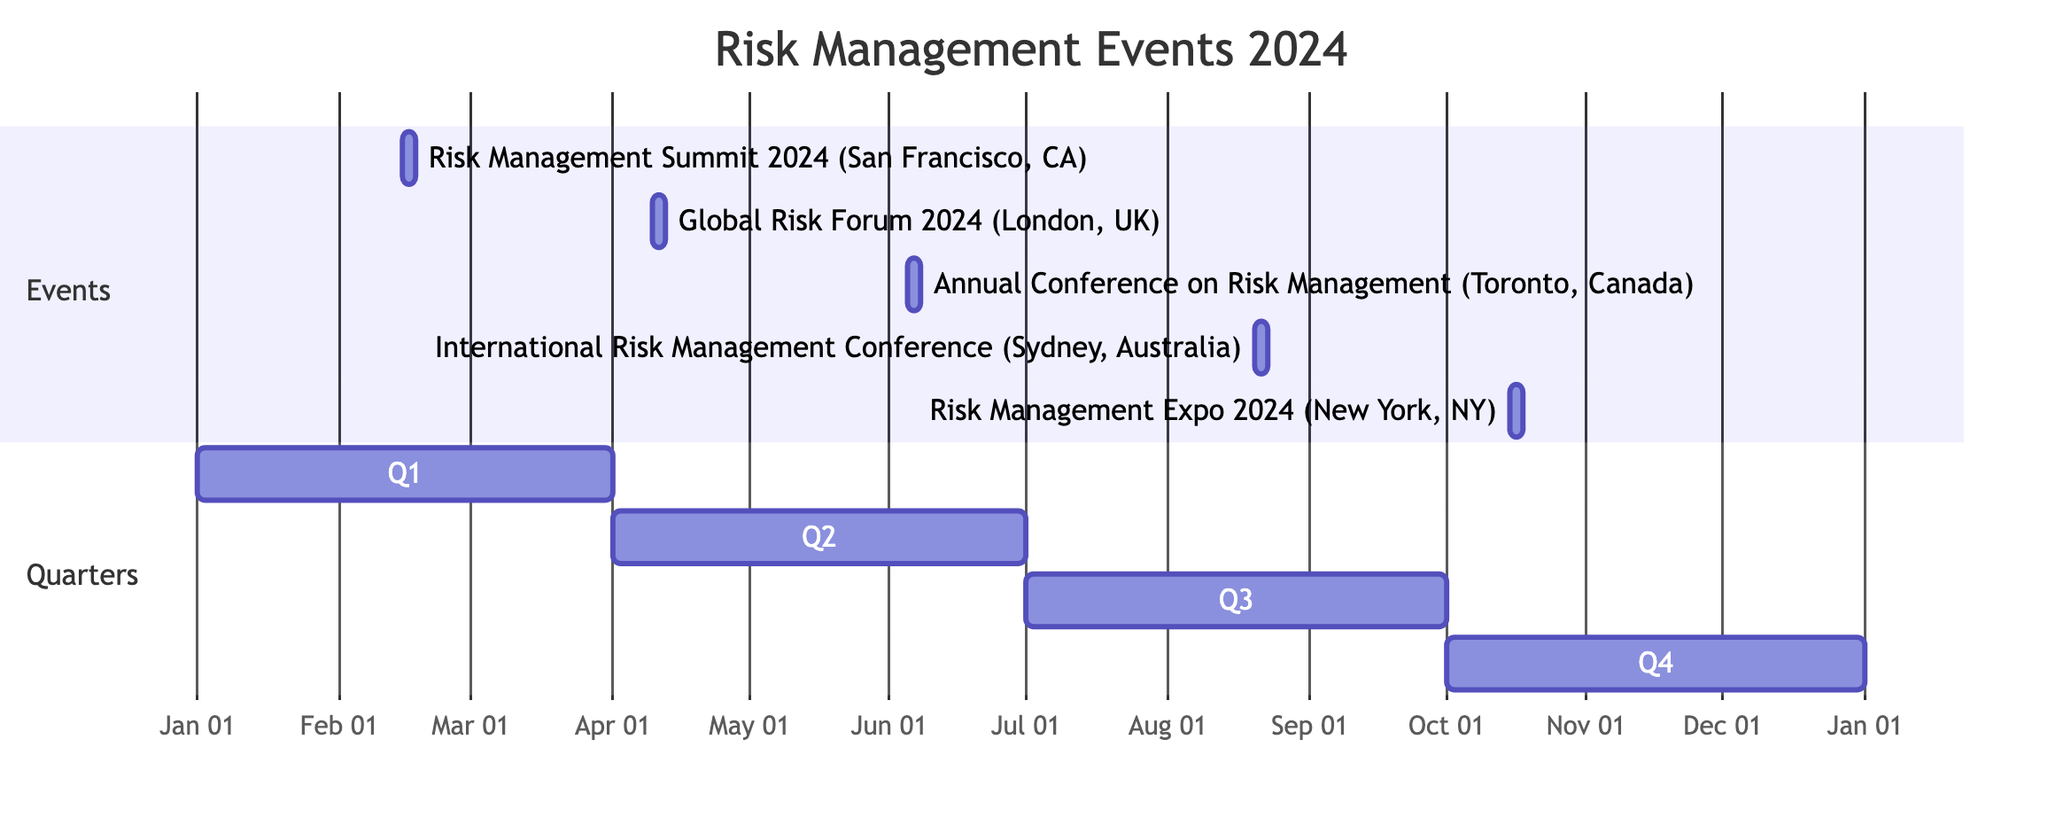What is the location of the Risk Management Summit 2024? The diagram lists the event and provides its corresponding location information next to it. By looking at the entry for the Risk Management Summit 2024, the location is specified as San Francisco, CA.
Answer: San Francisco, CA How many events are scheduled for the second quarter of 2024? By examining the diagram, I identify the events that fall within the second quarter (April to June 2024). The events listed are the Global Risk Forum 2024 and the Annual Conference on Risk Management, which totals two events.
Answer: 2 What are the dates for the International Risk Management Conference? The diagram indicates the start and end dates of the International Risk Management Conference. These are shown as August 20, 2024, and August 22, 2024.
Answer: August 20 - August 22, 2024 Which event takes place last in the year 2024? To find the last event, I look at the dates for all events in the Gantt Chart. The last event is the Risk Management Expo 2024, which ends on October 17, 2024.
Answer: Risk Management Expo 2024 Which city hosts the Annual Conference on Risk Management? The entry for the Annual Conference on Risk Management in the diagram includes the event name and its respective city. By checking the details, the hosting city is Toronto, Canada.
Answer: Toronto, Canada How many days does the Risk Management Expo 2024 last? The duration of the Risk Management Expo is determined from the end and start dates listed in the diagram. Since it starts on October 15, 2024, and ends on October 17, 2024, it lasts three days.
Answer: 3 days What event is scheduled for April? I scan the events in the diagram for one that occurs in April 2024. The entry shows that the Global Risk Forum 2024 takes place from April 10 to April 12, 2024.
Answer: Global Risk Forum 2024 Which event occurs in May 2024? The second quarter of 2024 includes the months of April, May, and June. However, by looking closely at the diagram, I see there are no events listed for May 2024; instead, the next event after the Global Risk Forum is in June.
Answer: None 